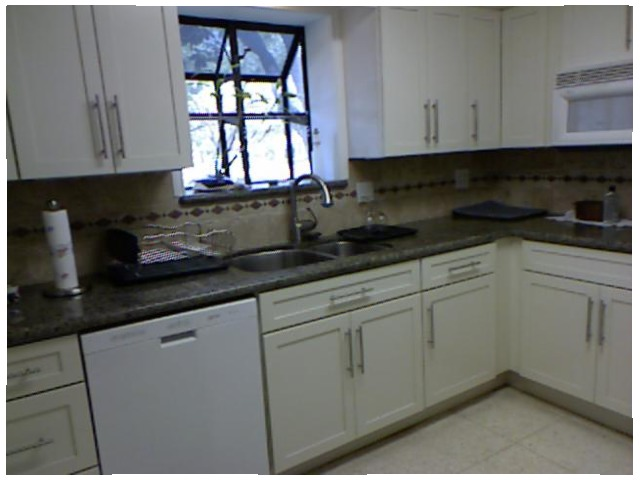<image>
Is the paper towel to the right of the drain pan? No. The paper towel is not to the right of the drain pan. The horizontal positioning shows a different relationship. 